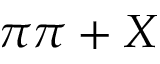Convert formula to latex. <formula><loc_0><loc_0><loc_500><loc_500>\pi \pi + X</formula> 